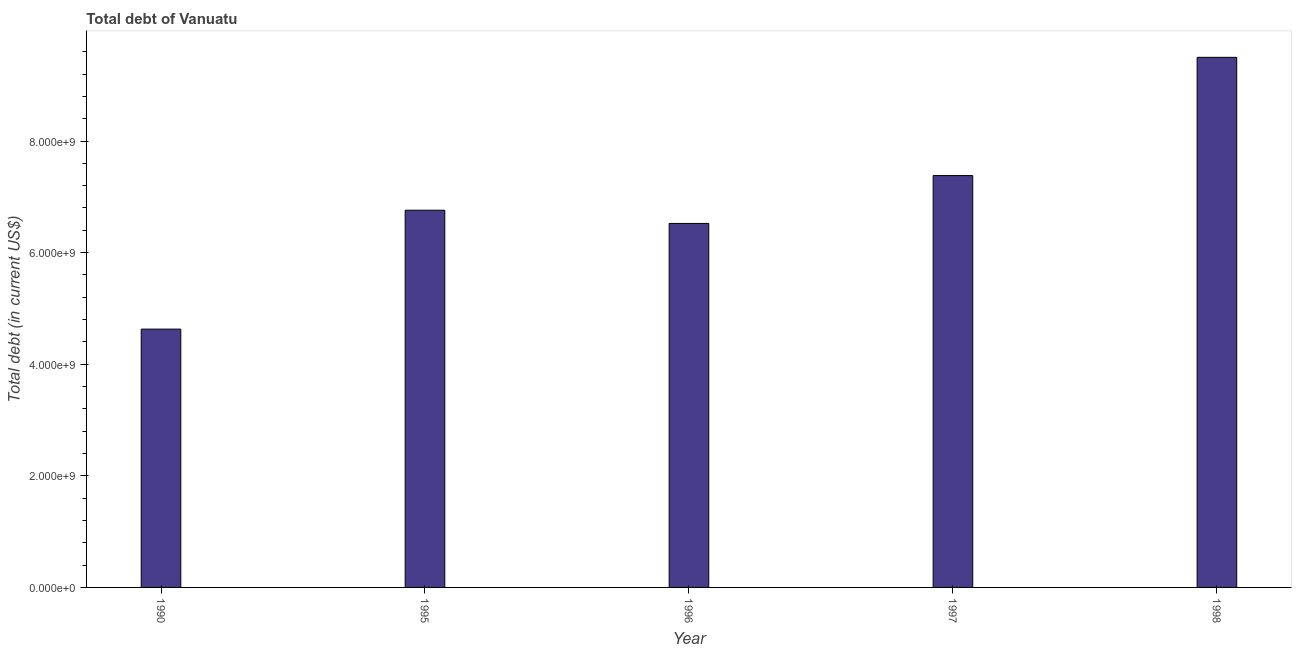Does the graph contain grids?
Your response must be concise. No. What is the title of the graph?
Ensure brevity in your answer.  Total debt of Vanuatu. What is the label or title of the X-axis?
Provide a succinct answer. Year. What is the label or title of the Y-axis?
Ensure brevity in your answer.  Total debt (in current US$). What is the total debt in 1997?
Keep it short and to the point. 7.38e+09. Across all years, what is the maximum total debt?
Your answer should be very brief. 9.50e+09. Across all years, what is the minimum total debt?
Make the answer very short. 4.63e+09. In which year was the total debt minimum?
Your response must be concise. 1990. What is the sum of the total debt?
Keep it short and to the point. 3.48e+1. What is the difference between the total debt in 1995 and 1997?
Your answer should be compact. -6.21e+08. What is the average total debt per year?
Provide a succinct answer. 6.96e+09. What is the median total debt?
Provide a short and direct response. 6.76e+09. What is the ratio of the total debt in 1990 to that in 1996?
Ensure brevity in your answer.  0.71. Is the total debt in 1990 less than that in 1995?
Your answer should be compact. Yes. Is the difference between the total debt in 1990 and 1995 greater than the difference between any two years?
Keep it short and to the point. No. What is the difference between the highest and the second highest total debt?
Your answer should be compact. 2.12e+09. What is the difference between the highest and the lowest total debt?
Give a very brief answer. 4.87e+09. Are all the bars in the graph horizontal?
Your answer should be compact. No. Are the values on the major ticks of Y-axis written in scientific E-notation?
Ensure brevity in your answer.  Yes. What is the Total debt (in current US$) in 1990?
Provide a succinct answer. 4.63e+09. What is the Total debt (in current US$) of 1995?
Offer a very short reply. 6.76e+09. What is the Total debt (in current US$) of 1996?
Offer a terse response. 6.52e+09. What is the Total debt (in current US$) of 1997?
Keep it short and to the point. 7.38e+09. What is the Total debt (in current US$) of 1998?
Your response must be concise. 9.50e+09. What is the difference between the Total debt (in current US$) in 1990 and 1995?
Your response must be concise. -2.13e+09. What is the difference between the Total debt (in current US$) in 1990 and 1996?
Make the answer very short. -1.89e+09. What is the difference between the Total debt (in current US$) in 1990 and 1997?
Provide a short and direct response. -2.75e+09. What is the difference between the Total debt (in current US$) in 1990 and 1998?
Your response must be concise. -4.87e+09. What is the difference between the Total debt (in current US$) in 1995 and 1996?
Your answer should be very brief. 2.37e+08. What is the difference between the Total debt (in current US$) in 1995 and 1997?
Offer a terse response. -6.21e+08. What is the difference between the Total debt (in current US$) in 1995 and 1998?
Make the answer very short. -2.74e+09. What is the difference between the Total debt (in current US$) in 1996 and 1997?
Keep it short and to the point. -8.58e+08. What is the difference between the Total debt (in current US$) in 1996 and 1998?
Ensure brevity in your answer.  -2.98e+09. What is the difference between the Total debt (in current US$) in 1997 and 1998?
Provide a short and direct response. -2.12e+09. What is the ratio of the Total debt (in current US$) in 1990 to that in 1995?
Ensure brevity in your answer.  0.69. What is the ratio of the Total debt (in current US$) in 1990 to that in 1996?
Your answer should be very brief. 0.71. What is the ratio of the Total debt (in current US$) in 1990 to that in 1997?
Ensure brevity in your answer.  0.63. What is the ratio of the Total debt (in current US$) in 1990 to that in 1998?
Keep it short and to the point. 0.49. What is the ratio of the Total debt (in current US$) in 1995 to that in 1996?
Provide a short and direct response. 1.04. What is the ratio of the Total debt (in current US$) in 1995 to that in 1997?
Offer a very short reply. 0.92. What is the ratio of the Total debt (in current US$) in 1995 to that in 1998?
Ensure brevity in your answer.  0.71. What is the ratio of the Total debt (in current US$) in 1996 to that in 1997?
Make the answer very short. 0.88. What is the ratio of the Total debt (in current US$) in 1996 to that in 1998?
Keep it short and to the point. 0.69. What is the ratio of the Total debt (in current US$) in 1997 to that in 1998?
Your response must be concise. 0.78. 